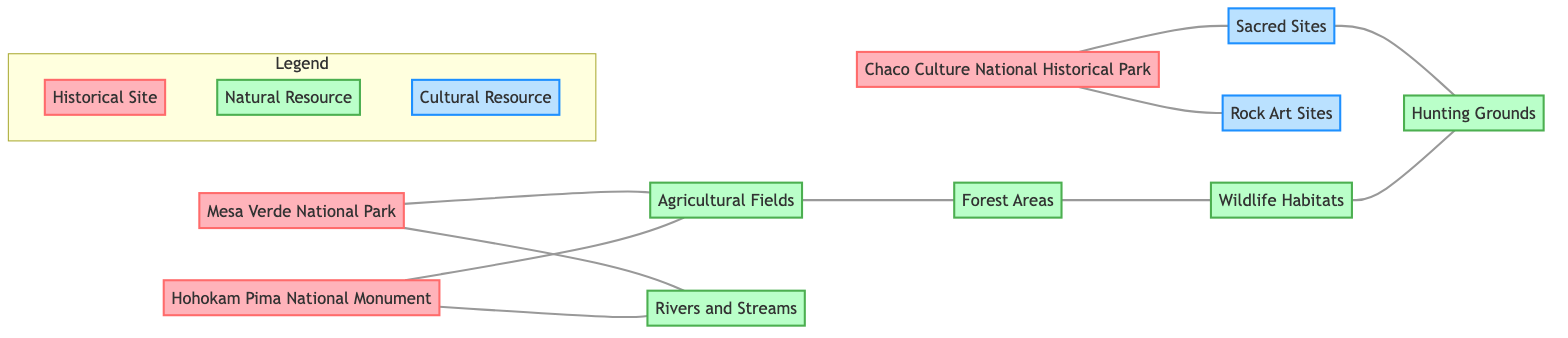What is the total number of historical cultural sites in the diagram? There are three historical cultural sites present in the diagram: Mesa Verde National Park, Chaco Culture National Historical Park, and Hohokam Pima National Monument.
Answer: 3 Which natural resource is associated with Mesa Verde National Park? The diagram shows that Mesa Verde National Park has relationships with two natural resources: Agricultural Fields and Rivers and Streams.
Answer: Agricultural Fields, Rivers and Streams What type of relationship exists between Chaco Culture National Historical Park and Sacred Sites? The relationship between Chaco Culture National Historical Park and Sacred Sites is described as "Association" in the diagram.
Answer: Association How many edges are connected to the Agricultural Fields? Agricultural Fields is connected to three other nodes: Mesa Verde National Park, Hohokam Pima National Monument, and Forest Areas, indicating three edges.
Answer: 3 Which cultural resource is in proximity to Chaco Culture National Historical Park? The only cultural resource listed in proximity to Chaco Culture National Historical Park is Rock Art Sites, as indicated by the relationship in the diagram.
Answer: Rock Art Sites What is the relationship type between Wildlife Habitats and Hunting Grounds? The relationship between Wildlife Habitats and Hunting Grounds is described as "Overlap" in the diagram.
Answer: Overlap Name one ecological relationship shown in the diagram involving Forest Areas. The diagram indicates an "Overlap" relationship between Forest Areas and Wildlife Habitats, demonstrating an ecological interaction.
Answer: Overlap Which historical cultural site has a past usage connection with Agricultural Fields? Hohokam Pima National Monument has a "Past Usage" connection with Agricultural Fields according to the diagram.
Answer: Hohokam Pima National Monument How many cultural resources are represented in the diagram? There are two cultural resources in the diagram: Sacred Sites and Rock Art Sites, making a total of two represented.
Answer: 2 